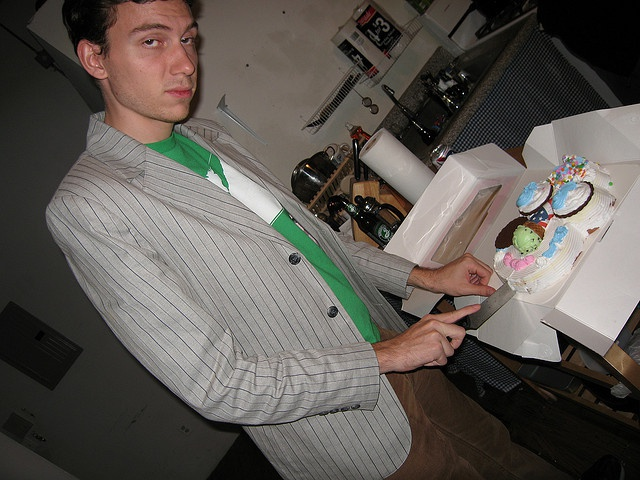Describe the objects in this image and their specific colors. I can see people in black, darkgray, and gray tones, cake in black, darkgray, and lightgray tones, sink in black, gray, and darkgreen tones, bottle in black, gray, darkgray, and darkgreen tones, and knife in black and gray tones in this image. 